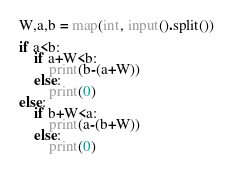Convert code to text. <code><loc_0><loc_0><loc_500><loc_500><_Python_>W,a,b = map(int, input().split())

if a<b:
	if a+W<b:
		print(b-(a+W))
	else:
		print(0)
else:
	if b+W<a:
		print(a-(b+W))
	else:
		print(0)</code> 